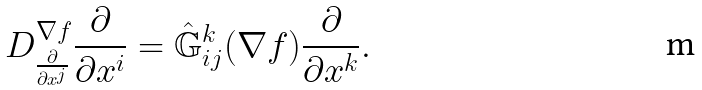<formula> <loc_0><loc_0><loc_500><loc_500>D ^ { \nabla f } _ { \frac { \partial } { \partial x ^ { j } } } \frac { \partial } { \partial x ^ { i } } = \hat { \mathbb { G } } ^ { k } _ { i j } ( \nabla f ) \frac { \partial } { \partial x ^ { k } } .</formula> 